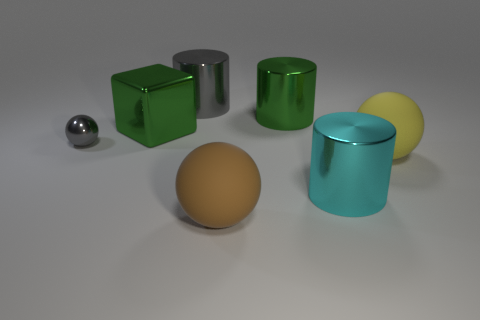Add 1 big cyan shiny balls. How many objects exist? 8 Subtract all cyan cylinders. How many cylinders are left? 2 Subtract 2 cylinders. How many cylinders are left? 1 Subtract all balls. How many objects are left? 4 Subtract 0 blue spheres. How many objects are left? 7 Subtract all green cylinders. Subtract all brown spheres. How many cylinders are left? 2 Subtract all brown objects. Subtract all green cubes. How many objects are left? 5 Add 4 green things. How many green things are left? 6 Add 6 tiny rubber balls. How many tiny rubber balls exist? 6 